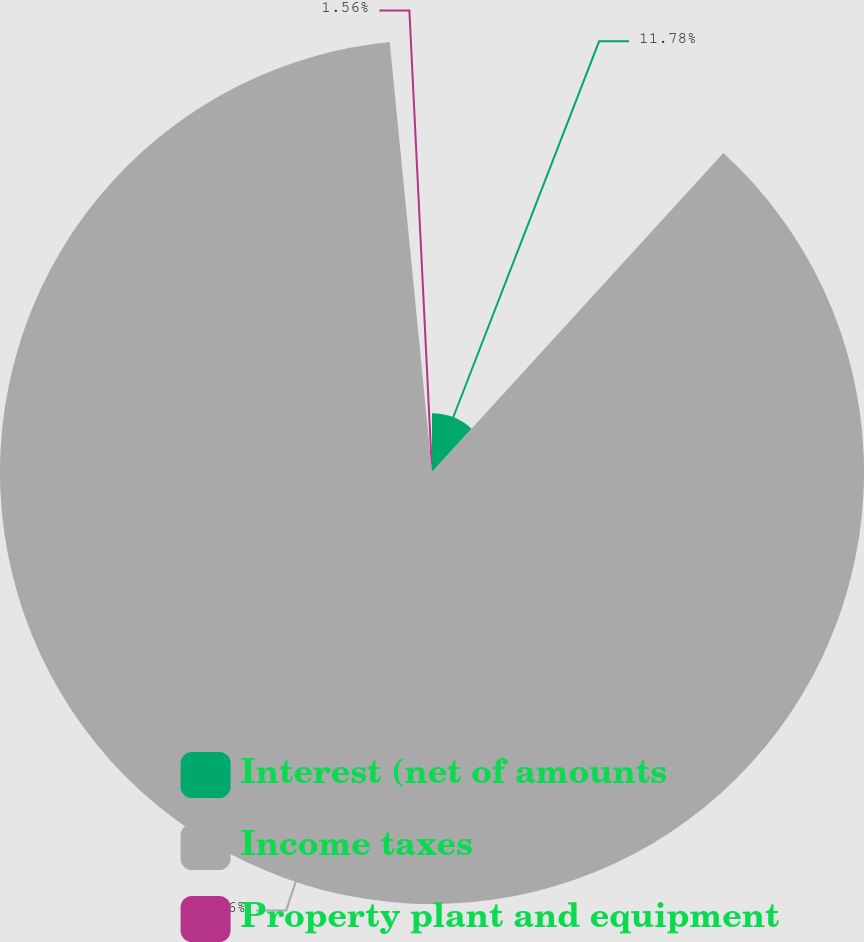<chart> <loc_0><loc_0><loc_500><loc_500><pie_chart><fcel>Interest (net of amounts<fcel>Income taxes<fcel>Property plant and equipment<nl><fcel>11.78%<fcel>86.66%<fcel>1.56%<nl></chart> 